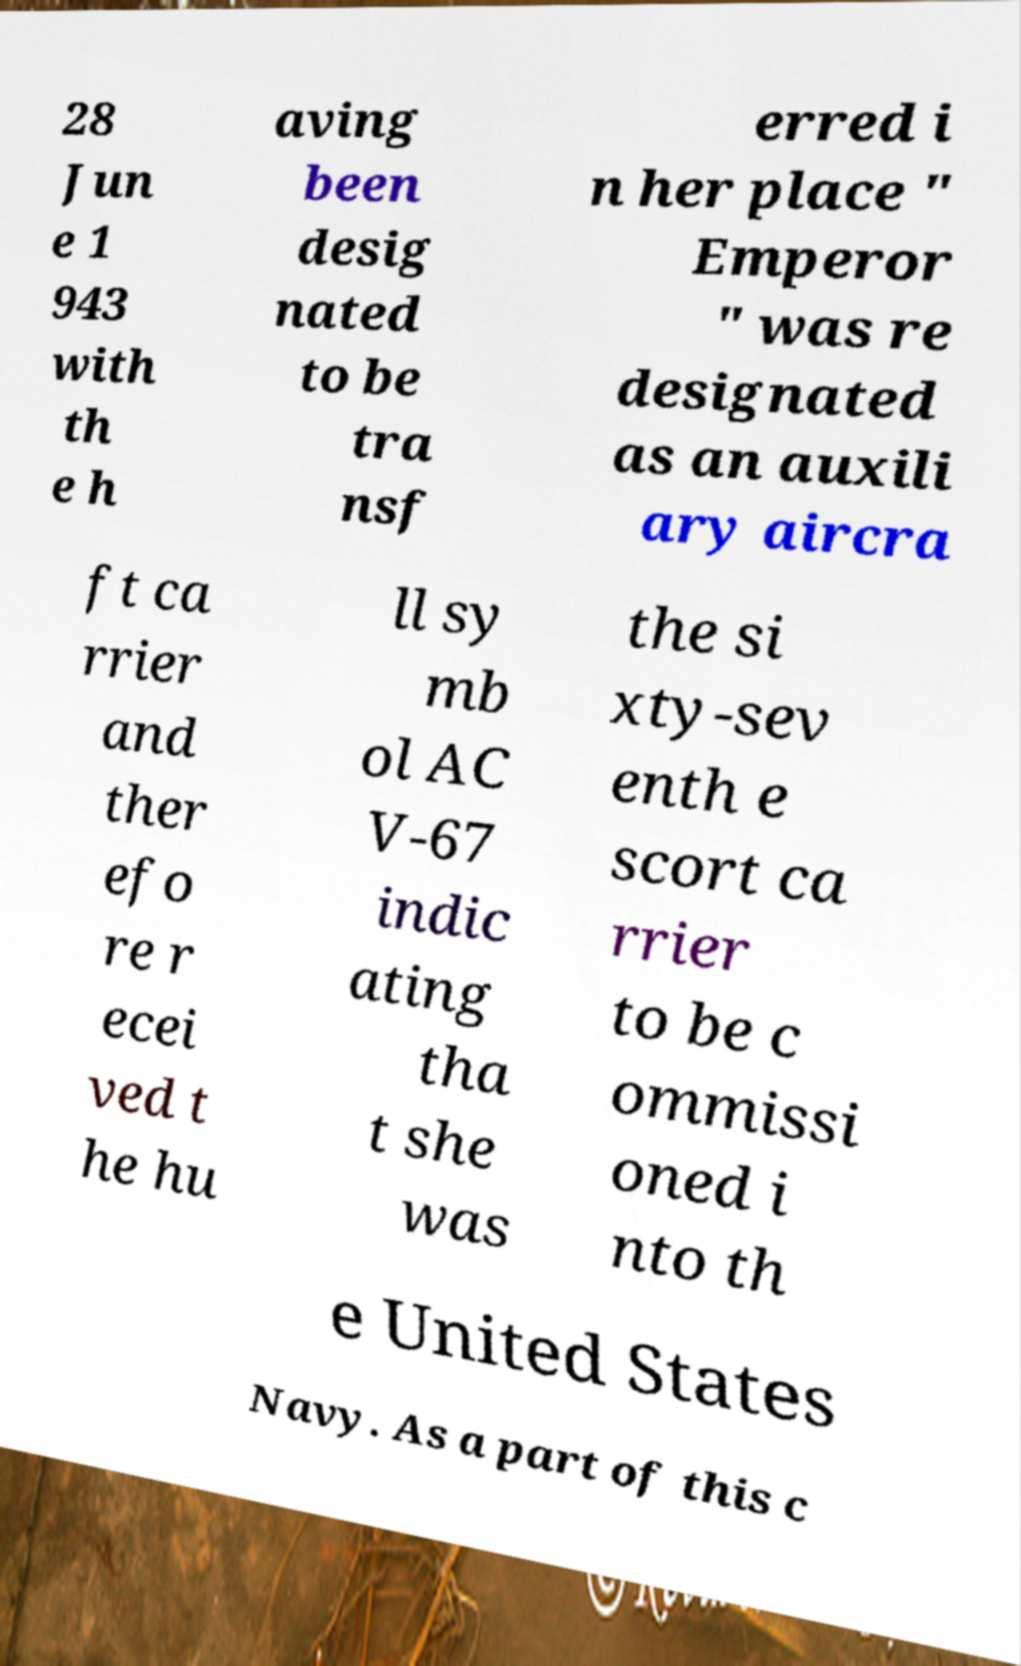For documentation purposes, I need the text within this image transcribed. Could you provide that? 28 Jun e 1 943 with th e h aving been desig nated to be tra nsf erred i n her place " Emperor " was re designated as an auxili ary aircra ft ca rrier and ther efo re r ecei ved t he hu ll sy mb ol AC V-67 indic ating tha t she was the si xty-sev enth e scort ca rrier to be c ommissi oned i nto th e United States Navy. As a part of this c 